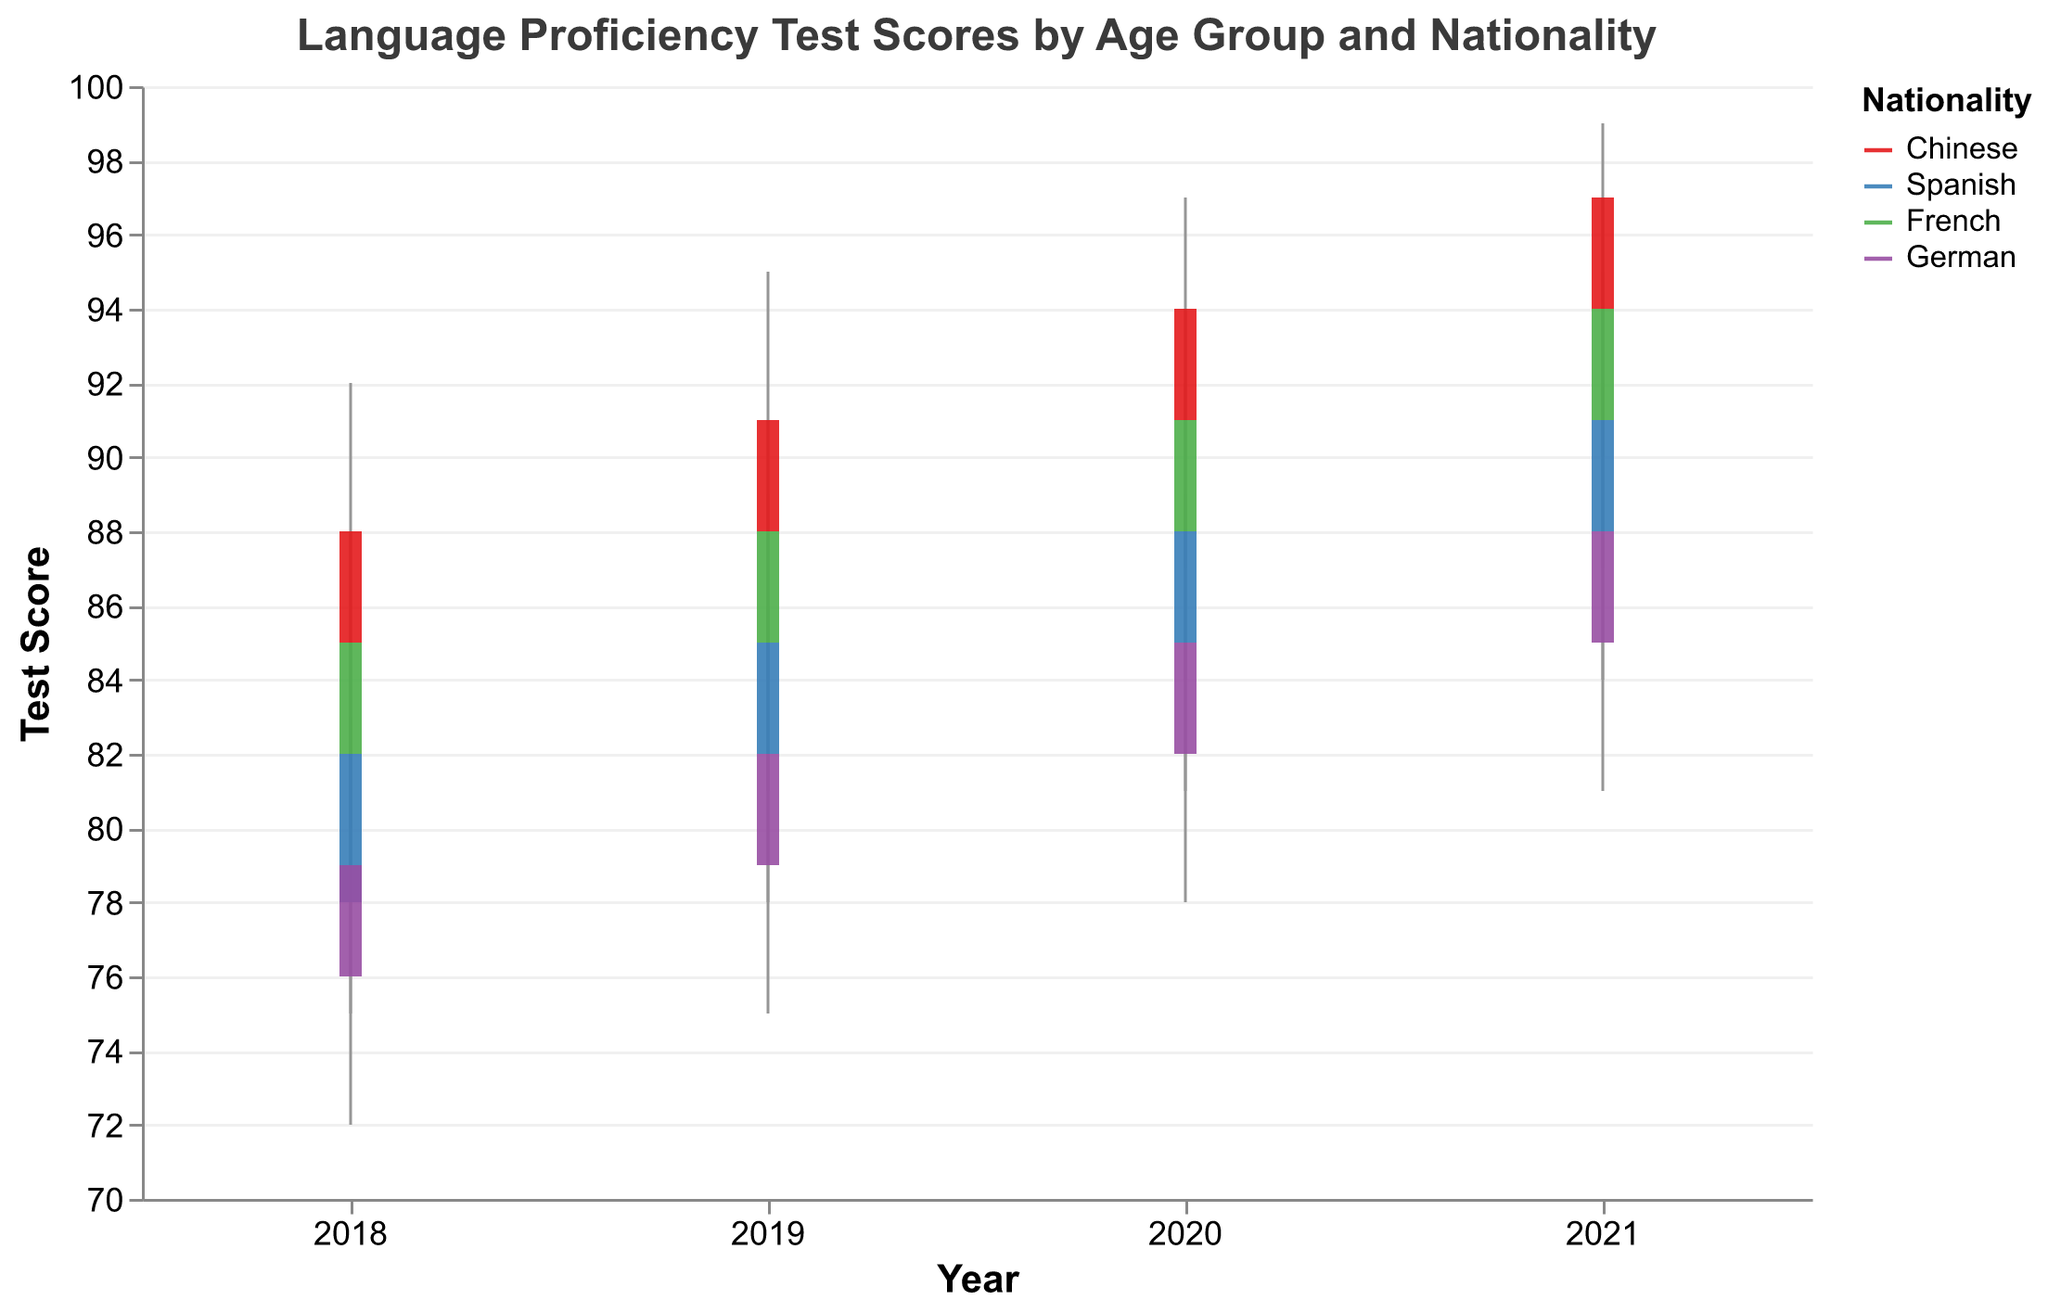What is the highest test score for the Chinese nationality in 2020? The highest test score is found by looking at the "High" values in the 2020 section for Chinese nationality data points. The "High" value for "Chinese" in 2020 is 97.
Answer: 97 What is the average closing test score for the age group 18-25 across all years? Sum the closing scores for the age group 18-25 across all years and divide by the number of data points (4 years). The scores are 88, 91, 94, 97. Thus, (88 + 91 + 94 + 97) / 4 = 370 / 4 = 92.5.
Answer: 92.5 Which nationality has the highest opening test score in 2021, and what is the score? Check the 2021 section for all nationalities' "Open" values (Chinese: 94, Spanish: 88, French: 91, German: 85). The highest opening test score in 2021 is for Chinese with a score of 94.
Answer: Chinese, 94 How does the closing test score for the German nationality change from 2018 to 2021? Subtract the 2018 closing score of German nationality from the 2021 closing score (2018: 79, 2021: 88). The change is 88 - 79 = 9.
Answer: 9 What is the range of test scores for the French nationality in 2019? Find the "High" and "Low" values for the French nationality in 2019 (High: 91, Low: 81). The range is calculated as 91 - 81 = 10.
Answer: 10 In which year did the Spanish nationality achieve the same closing test score as any other nationality in any year? The Spanish closing scores are 82 (2018), 85 (2019), 88 (2020), and 91 (2021). The German closing score in 2020 is also 85. Therefore, in 2019, the Spanish closing score matched the German closing score in 2020.
Answer: 2019 (matched with German in 2020) Which age group saw the biggest increase in their closing test score from 2018 to 2021? Calculate the closing test score difference for each age group between 2018 and 2021. The differences are: 18-25: 97 - 88 = 9, 26-35: 91 - 82 = 9, 36-45: 94 - 85 = 9, 46+: 88 - 79 = 9. All age groups saw an equal increase of 9 points from 2018 to 2021.
Answer: All age groups, 9 What was the lowest test score recorded for the Spanish nationality over the entire period? The lowest scores for the Spanish nationality are: 75 (2018), 78 (2019), 81 (2020), 84 (2021). The overall lowest score is 75.
Answer: 75 